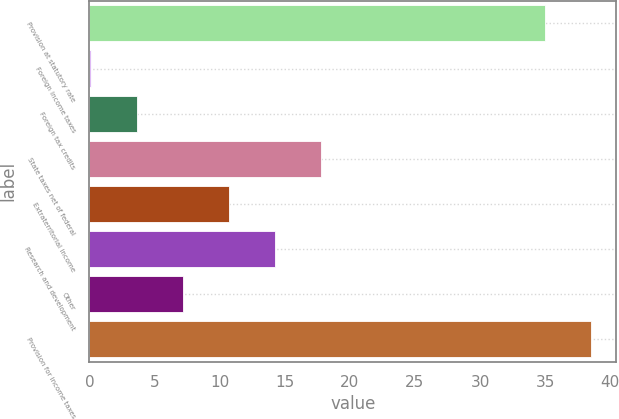Convert chart to OTSL. <chart><loc_0><loc_0><loc_500><loc_500><bar_chart><fcel>Provision at statutory rate<fcel>Foreign income taxes<fcel>Foreign tax credits<fcel>State taxes net of federal<fcel>Extraterritorial income<fcel>Research and development<fcel>Other<fcel>Provision for income taxes<nl><fcel>35<fcel>0.1<fcel>3.64<fcel>17.8<fcel>10.72<fcel>14.26<fcel>7.18<fcel>38.54<nl></chart> 